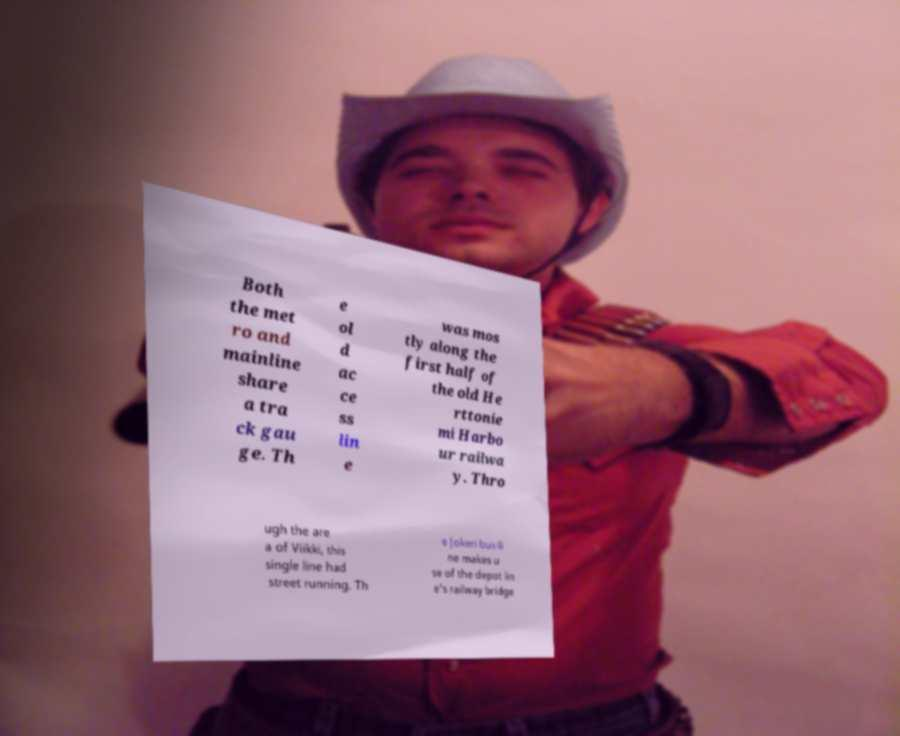Can you accurately transcribe the text from the provided image for me? Both the met ro and mainline share a tra ck gau ge. Th e ol d ac ce ss lin e was mos tly along the first half of the old He rttonie mi Harbo ur railwa y. Thro ugh the are a of Viikki, this single line had street running. Th e Jokeri bus-li ne makes u se of the depot lin e's railway bridge 